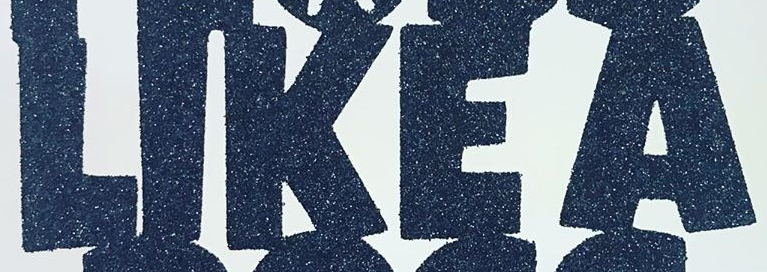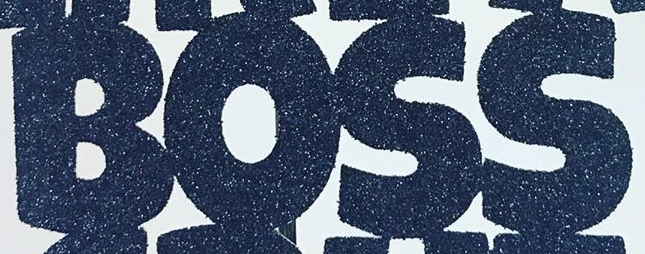What text is displayed in these images sequentially, separated by a semicolon? LIKEA; BOSS 